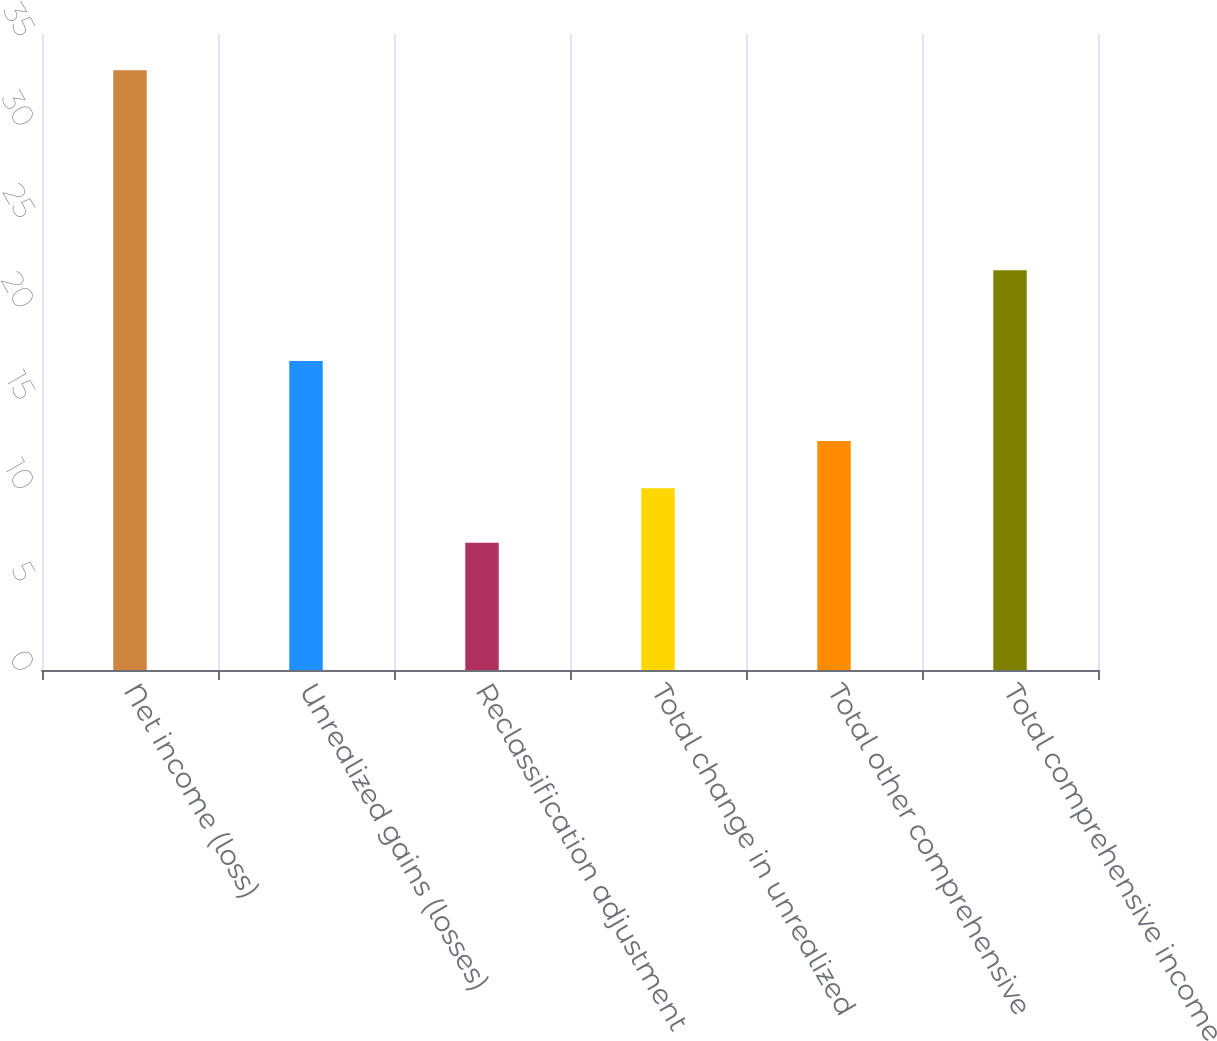Convert chart to OTSL. <chart><loc_0><loc_0><loc_500><loc_500><bar_chart><fcel>Net income (loss)<fcel>Unrealized gains (losses)<fcel>Reclassification adjustment<fcel>Total change in unrealized<fcel>Total other comprehensive<fcel>Total comprehensive income<nl><fcel>33<fcel>17<fcel>7<fcel>10<fcel>12.6<fcel>22<nl></chart> 